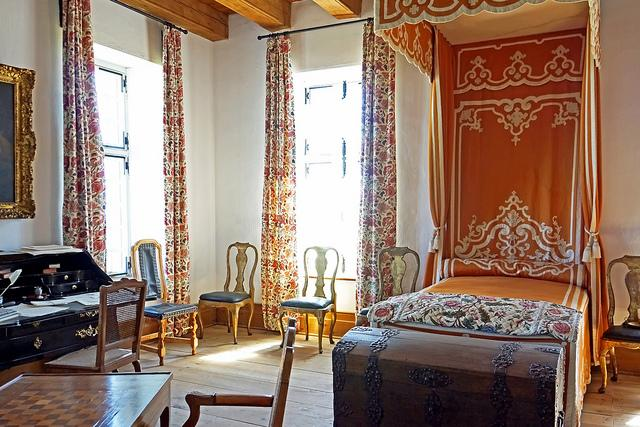What is the brown table at the left bottom corner for? Please explain your reasoning. playing chess. A chess board is in a room and a chair is on one side of it. 